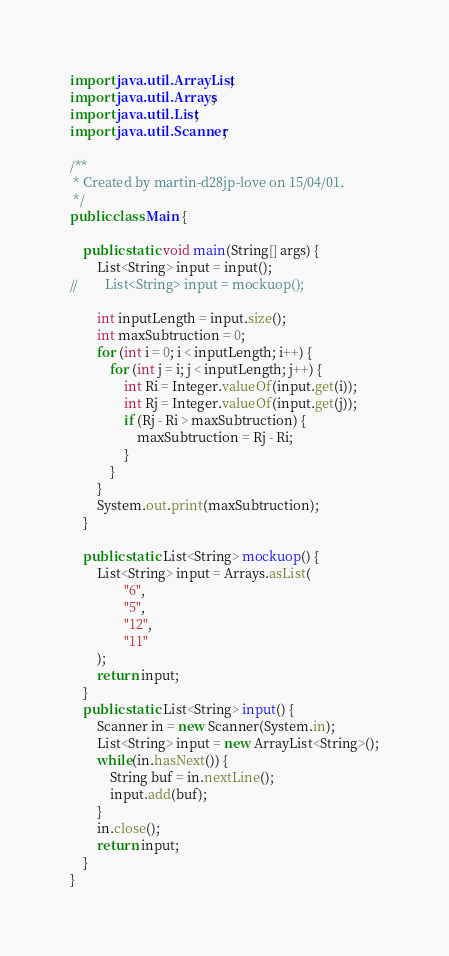<code> <loc_0><loc_0><loc_500><loc_500><_Java_>import java.util.ArrayList;
import java.util.Arrays;
import java.util.List;
import java.util.Scanner;

/**
 * Created by martin-d28jp-love on 15/04/01.
 */
public class Main {

    public static void main(String[] args) {
        List<String> input = input();
//        List<String> input = mockuop();

        int inputLength = input.size();
        int maxSubtruction = 0;
        for (int i = 0; i < inputLength; i++) {
            for (int j = i; j < inputLength; j++) {
                int Ri = Integer.valueOf(input.get(i));
                int Rj = Integer.valueOf(input.get(j));
                if (Rj - Ri > maxSubtruction) {
                    maxSubtruction = Rj - Ri;
                }
            }
        }
        System.out.print(maxSubtruction);
    }

    public static List<String> mockuop() {
        List<String> input = Arrays.asList(
                "6",
                "5",
                "12",
                "11"
        );
        return input;
    }
    public static List<String> input() {
        Scanner in = new Scanner(System.in);
        List<String> input = new ArrayList<String>();
        while(in.hasNext()) {
            String buf = in.nextLine();
            input.add(buf);
        }
        in.close();
        return input;
    }
}</code> 